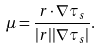<formula> <loc_0><loc_0><loc_500><loc_500>\mu = \frac { r \cdot \nabla \tau _ { s } } { | r | | \nabla \tau _ { s } | } .</formula> 